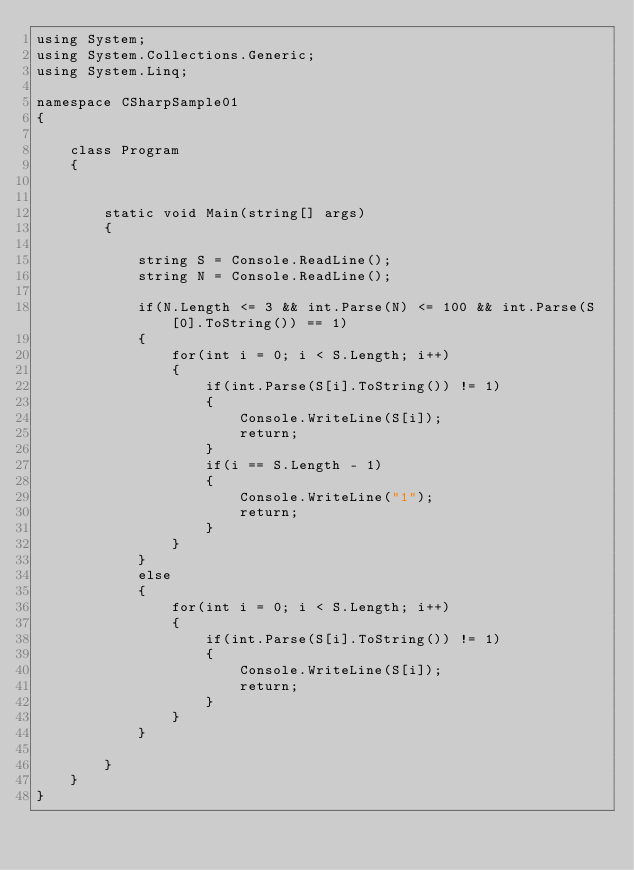Convert code to text. <code><loc_0><loc_0><loc_500><loc_500><_C#_>using System;
using System.Collections.Generic;
using System.Linq;

namespace CSharpSample01
{ 

    class Program
    {

        
        static void Main(string[] args)
        {

            string S = Console.ReadLine();
            string N = Console.ReadLine();

            if(N.Length <= 3 && int.Parse(N) <= 100 && int.Parse(S[0].ToString()) == 1)
            {
                for(int i = 0; i < S.Length; i++)
                {
                    if(int.Parse(S[i].ToString()) != 1)
                    {
                        Console.WriteLine(S[i]);
                        return;
                    }
                    if(i == S.Length - 1)
                    {
                        Console.WriteLine("1");
                        return;
                    }
                }
            }
            else
            {
                for(int i = 0; i < S.Length; i++)
                {
                    if(int.Parse(S[i].ToString()) != 1)
                    {
                        Console.WriteLine(S[i]);
                        return;
                    }
                }
            }

        }
    }
}
</code> 